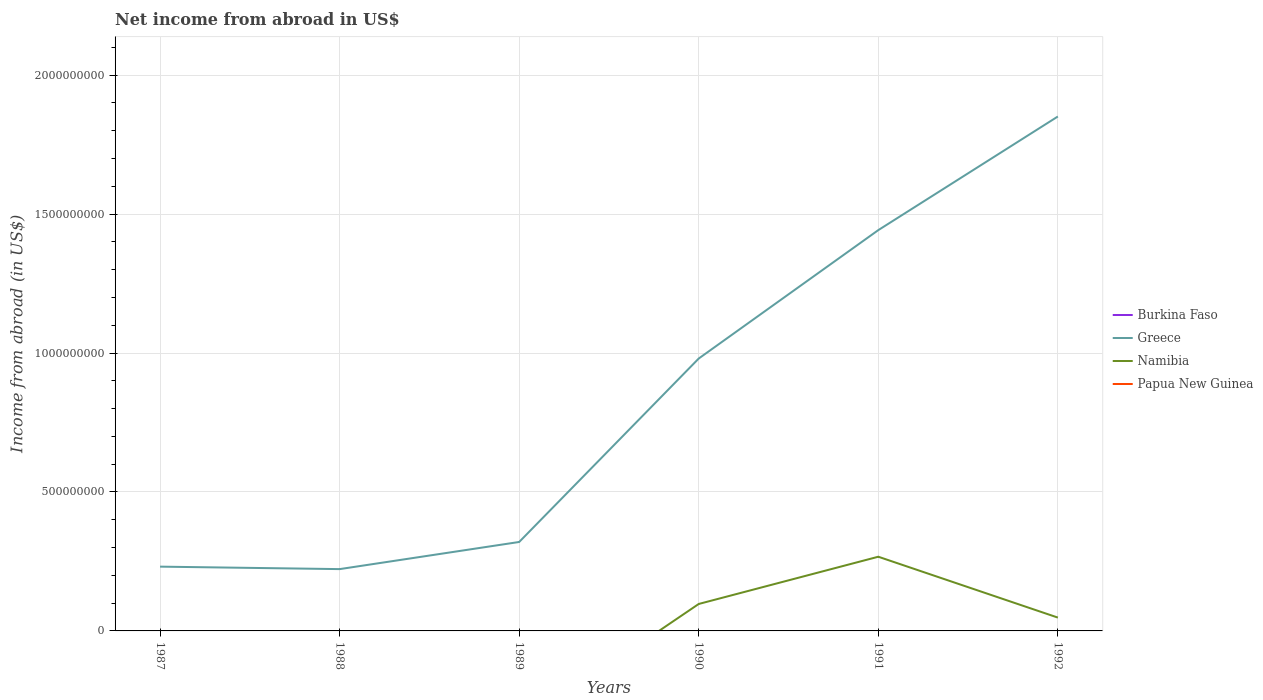Does the line corresponding to Greece intersect with the line corresponding to Namibia?
Keep it short and to the point. No. Is the number of lines equal to the number of legend labels?
Provide a short and direct response. No. Across all years, what is the maximum net income from abroad in Greece?
Give a very brief answer. 2.22e+08. What is the total net income from abroad in Namibia in the graph?
Your response must be concise. 4.90e+07. What is the difference between the highest and the second highest net income from abroad in Namibia?
Offer a very short reply. 2.67e+08. What is the difference between the highest and the lowest net income from abroad in Greece?
Offer a terse response. 3. How are the legend labels stacked?
Give a very brief answer. Vertical. What is the title of the graph?
Provide a succinct answer. Net income from abroad in US$. What is the label or title of the X-axis?
Offer a very short reply. Years. What is the label or title of the Y-axis?
Offer a very short reply. Income from abroad (in US$). What is the Income from abroad (in US$) in Greece in 1987?
Your response must be concise. 2.31e+08. What is the Income from abroad (in US$) in Greece in 1988?
Keep it short and to the point. 2.22e+08. What is the Income from abroad (in US$) of Namibia in 1988?
Ensure brevity in your answer.  0. What is the Income from abroad (in US$) of Papua New Guinea in 1988?
Ensure brevity in your answer.  0. What is the Income from abroad (in US$) in Burkina Faso in 1989?
Give a very brief answer. 0. What is the Income from abroad (in US$) of Greece in 1989?
Give a very brief answer. 3.20e+08. What is the Income from abroad (in US$) of Papua New Guinea in 1989?
Provide a succinct answer. 0. What is the Income from abroad (in US$) of Burkina Faso in 1990?
Offer a terse response. 0. What is the Income from abroad (in US$) in Greece in 1990?
Ensure brevity in your answer.  9.80e+08. What is the Income from abroad (in US$) of Namibia in 1990?
Provide a short and direct response. 9.70e+07. What is the Income from abroad (in US$) in Papua New Guinea in 1990?
Provide a succinct answer. 0. What is the Income from abroad (in US$) of Burkina Faso in 1991?
Provide a succinct answer. 0. What is the Income from abroad (in US$) of Greece in 1991?
Provide a short and direct response. 1.44e+09. What is the Income from abroad (in US$) in Namibia in 1991?
Offer a terse response. 2.67e+08. What is the Income from abroad (in US$) in Papua New Guinea in 1991?
Provide a succinct answer. 0. What is the Income from abroad (in US$) in Greece in 1992?
Ensure brevity in your answer.  1.85e+09. What is the Income from abroad (in US$) in Namibia in 1992?
Ensure brevity in your answer.  4.80e+07. Across all years, what is the maximum Income from abroad (in US$) in Greece?
Offer a terse response. 1.85e+09. Across all years, what is the maximum Income from abroad (in US$) of Namibia?
Make the answer very short. 2.67e+08. Across all years, what is the minimum Income from abroad (in US$) in Greece?
Offer a very short reply. 2.22e+08. Across all years, what is the minimum Income from abroad (in US$) of Namibia?
Give a very brief answer. 0. What is the total Income from abroad (in US$) of Burkina Faso in the graph?
Keep it short and to the point. 0. What is the total Income from abroad (in US$) in Greece in the graph?
Your answer should be very brief. 5.05e+09. What is the total Income from abroad (in US$) of Namibia in the graph?
Give a very brief answer. 4.12e+08. What is the total Income from abroad (in US$) in Papua New Guinea in the graph?
Make the answer very short. 0. What is the difference between the Income from abroad (in US$) of Greece in 1987 and that in 1988?
Your answer should be compact. 8.92e+06. What is the difference between the Income from abroad (in US$) of Greece in 1987 and that in 1989?
Offer a terse response. -8.87e+07. What is the difference between the Income from abroad (in US$) of Greece in 1987 and that in 1990?
Make the answer very short. -7.49e+08. What is the difference between the Income from abroad (in US$) in Greece in 1987 and that in 1991?
Your answer should be very brief. -1.21e+09. What is the difference between the Income from abroad (in US$) in Greece in 1987 and that in 1992?
Provide a succinct answer. -1.62e+09. What is the difference between the Income from abroad (in US$) in Greece in 1988 and that in 1989?
Make the answer very short. -9.77e+07. What is the difference between the Income from abroad (in US$) in Greece in 1988 and that in 1990?
Keep it short and to the point. -7.58e+08. What is the difference between the Income from abroad (in US$) of Greece in 1988 and that in 1991?
Keep it short and to the point. -1.22e+09. What is the difference between the Income from abroad (in US$) in Greece in 1988 and that in 1992?
Provide a short and direct response. -1.63e+09. What is the difference between the Income from abroad (in US$) of Greece in 1989 and that in 1990?
Ensure brevity in your answer.  -6.60e+08. What is the difference between the Income from abroad (in US$) of Greece in 1989 and that in 1991?
Provide a short and direct response. -1.12e+09. What is the difference between the Income from abroad (in US$) of Greece in 1989 and that in 1992?
Provide a short and direct response. -1.53e+09. What is the difference between the Income from abroad (in US$) in Greece in 1990 and that in 1991?
Ensure brevity in your answer.  -4.62e+08. What is the difference between the Income from abroad (in US$) in Namibia in 1990 and that in 1991?
Your response must be concise. -1.70e+08. What is the difference between the Income from abroad (in US$) of Greece in 1990 and that in 1992?
Your response must be concise. -8.71e+08. What is the difference between the Income from abroad (in US$) in Namibia in 1990 and that in 1992?
Give a very brief answer. 4.90e+07. What is the difference between the Income from abroad (in US$) in Greece in 1991 and that in 1992?
Keep it short and to the point. -4.09e+08. What is the difference between the Income from abroad (in US$) of Namibia in 1991 and that in 1992?
Offer a very short reply. 2.19e+08. What is the difference between the Income from abroad (in US$) of Greece in 1987 and the Income from abroad (in US$) of Namibia in 1990?
Your response must be concise. 1.34e+08. What is the difference between the Income from abroad (in US$) in Greece in 1987 and the Income from abroad (in US$) in Namibia in 1991?
Offer a very short reply. -3.57e+07. What is the difference between the Income from abroad (in US$) in Greece in 1987 and the Income from abroad (in US$) in Namibia in 1992?
Ensure brevity in your answer.  1.83e+08. What is the difference between the Income from abroad (in US$) in Greece in 1988 and the Income from abroad (in US$) in Namibia in 1990?
Your response must be concise. 1.25e+08. What is the difference between the Income from abroad (in US$) in Greece in 1988 and the Income from abroad (in US$) in Namibia in 1991?
Offer a very short reply. -4.46e+07. What is the difference between the Income from abroad (in US$) in Greece in 1988 and the Income from abroad (in US$) in Namibia in 1992?
Give a very brief answer. 1.74e+08. What is the difference between the Income from abroad (in US$) of Greece in 1989 and the Income from abroad (in US$) of Namibia in 1990?
Your answer should be very brief. 2.23e+08. What is the difference between the Income from abroad (in US$) in Greece in 1989 and the Income from abroad (in US$) in Namibia in 1991?
Offer a terse response. 5.31e+07. What is the difference between the Income from abroad (in US$) of Greece in 1989 and the Income from abroad (in US$) of Namibia in 1992?
Ensure brevity in your answer.  2.72e+08. What is the difference between the Income from abroad (in US$) of Greece in 1990 and the Income from abroad (in US$) of Namibia in 1991?
Make the answer very short. 7.13e+08. What is the difference between the Income from abroad (in US$) of Greece in 1990 and the Income from abroad (in US$) of Namibia in 1992?
Offer a very short reply. 9.32e+08. What is the difference between the Income from abroad (in US$) of Greece in 1991 and the Income from abroad (in US$) of Namibia in 1992?
Your answer should be compact. 1.39e+09. What is the average Income from abroad (in US$) of Greece per year?
Your response must be concise. 8.41e+08. What is the average Income from abroad (in US$) in Namibia per year?
Your answer should be compact. 6.87e+07. What is the average Income from abroad (in US$) of Papua New Guinea per year?
Offer a very short reply. 0. In the year 1990, what is the difference between the Income from abroad (in US$) in Greece and Income from abroad (in US$) in Namibia?
Provide a succinct answer. 8.83e+08. In the year 1991, what is the difference between the Income from abroad (in US$) of Greece and Income from abroad (in US$) of Namibia?
Make the answer very short. 1.18e+09. In the year 1992, what is the difference between the Income from abroad (in US$) of Greece and Income from abroad (in US$) of Namibia?
Make the answer very short. 1.80e+09. What is the ratio of the Income from abroad (in US$) in Greece in 1987 to that in 1988?
Keep it short and to the point. 1.04. What is the ratio of the Income from abroad (in US$) of Greece in 1987 to that in 1989?
Ensure brevity in your answer.  0.72. What is the ratio of the Income from abroad (in US$) in Greece in 1987 to that in 1990?
Provide a short and direct response. 0.24. What is the ratio of the Income from abroad (in US$) in Greece in 1987 to that in 1991?
Keep it short and to the point. 0.16. What is the ratio of the Income from abroad (in US$) in Greece in 1987 to that in 1992?
Your answer should be very brief. 0.12. What is the ratio of the Income from abroad (in US$) of Greece in 1988 to that in 1989?
Ensure brevity in your answer.  0.69. What is the ratio of the Income from abroad (in US$) of Greece in 1988 to that in 1990?
Give a very brief answer. 0.23. What is the ratio of the Income from abroad (in US$) of Greece in 1988 to that in 1991?
Keep it short and to the point. 0.15. What is the ratio of the Income from abroad (in US$) in Greece in 1988 to that in 1992?
Your response must be concise. 0.12. What is the ratio of the Income from abroad (in US$) in Greece in 1989 to that in 1990?
Provide a short and direct response. 0.33. What is the ratio of the Income from abroad (in US$) of Greece in 1989 to that in 1991?
Offer a very short reply. 0.22. What is the ratio of the Income from abroad (in US$) of Greece in 1989 to that in 1992?
Your answer should be very brief. 0.17. What is the ratio of the Income from abroad (in US$) of Greece in 1990 to that in 1991?
Give a very brief answer. 0.68. What is the ratio of the Income from abroad (in US$) in Namibia in 1990 to that in 1991?
Keep it short and to the point. 0.36. What is the ratio of the Income from abroad (in US$) of Greece in 1990 to that in 1992?
Make the answer very short. 0.53. What is the ratio of the Income from abroad (in US$) of Namibia in 1990 to that in 1992?
Provide a short and direct response. 2.02. What is the ratio of the Income from abroad (in US$) in Greece in 1991 to that in 1992?
Your response must be concise. 0.78. What is the ratio of the Income from abroad (in US$) in Namibia in 1991 to that in 1992?
Keep it short and to the point. 5.56. What is the difference between the highest and the second highest Income from abroad (in US$) in Greece?
Make the answer very short. 4.09e+08. What is the difference between the highest and the second highest Income from abroad (in US$) in Namibia?
Make the answer very short. 1.70e+08. What is the difference between the highest and the lowest Income from abroad (in US$) in Greece?
Offer a very short reply. 1.63e+09. What is the difference between the highest and the lowest Income from abroad (in US$) of Namibia?
Ensure brevity in your answer.  2.67e+08. 